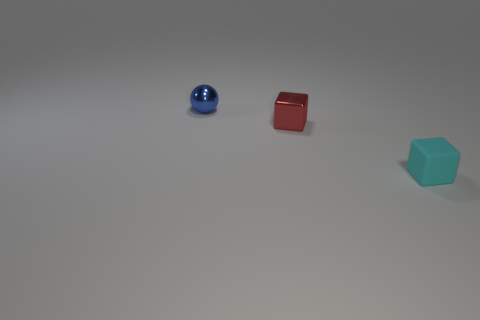Are there fewer metal balls that are behind the tiny blue metallic object than tiny rubber objects?
Make the answer very short. Yes. How many other matte blocks have the same size as the cyan rubber block?
Your response must be concise. 0. The tiny shiny object behind the small metal thing that is in front of the shiny object behind the tiny metal cube is what shape?
Your response must be concise. Sphere. There is a tiny shiny object on the right side of the blue thing; what is its color?
Give a very brief answer. Red. How many objects are either metallic things that are behind the red metallic block or objects that are behind the red cube?
Make the answer very short. 1. What number of other rubber objects are the same shape as the red thing?
Give a very brief answer. 1. There is a shiny thing that is the same size as the blue shiny sphere; what is its color?
Provide a succinct answer. Red. What is the color of the shiny thing that is in front of the tiny thing behind the tiny metal thing in front of the tiny metal sphere?
Ensure brevity in your answer.  Red. There is a blue object; is its size the same as the thing that is to the right of the small red cube?
Offer a terse response. Yes. What number of things are either spheres or red metal objects?
Your response must be concise. 2. 